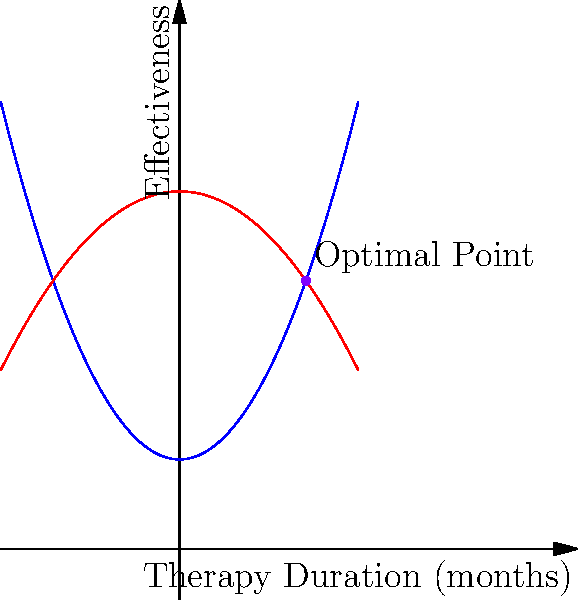The graph shows the effectiveness of two therapeutic approaches: Cognitive Behavioral Therapy (CBT) and Psychodynamic Therapy, as functions of therapy duration. CBT is represented by the function $f_1(x) = 0.5x^2 + 2$, and Psychodynamic Therapy by $f_2(x) = -0.25x^2 + 8$, where $x$ is the therapy duration in months. At what therapy duration does the combination of these approaches yield the highest overall effectiveness, and what is this maximum effectiveness value? To find the optimal point, we need to follow these steps:

1) The total effectiveness is the sum of both therapies: 
   $f(x) = f_1(x) + f_2(x) = (0.5x^2 + 2) + (-0.25x^2 + 8) = 0.25x^2 + 10$

2) To find the maximum, we differentiate $f(x)$ and set it to zero:
   $f'(x) = 0.5x = 0$

3) Solving this equation:
   $x = 0$

4) However, this gives us a minimum, not a maximum. The maximum occurs where the two curves intersect.

5) To find the intersection, we set the functions equal:
   $0.5x^2 + 2 = -0.25x^2 + 8$

6) Solving this equation:
   $0.75x^2 = 6$
   $x^2 = 8$
   $x = \pm 2\sqrt{2} \approx \pm 2.83$

7) Since therapy duration can't be negative, we take the positive value: $x \approx 2.83$ months.

8) The effectiveness at this point is:
   $f(2.83) = 0.5(2.83)^2 + 2 = 0.25(2.83)^2 + 8 \approx 6.0$

Therefore, the optimal therapy duration is approximately 2.83 months, with a maximum effectiveness of about 6.0.
Answer: Optimal duration: 2.83 months; Maximum effectiveness: 6.0 